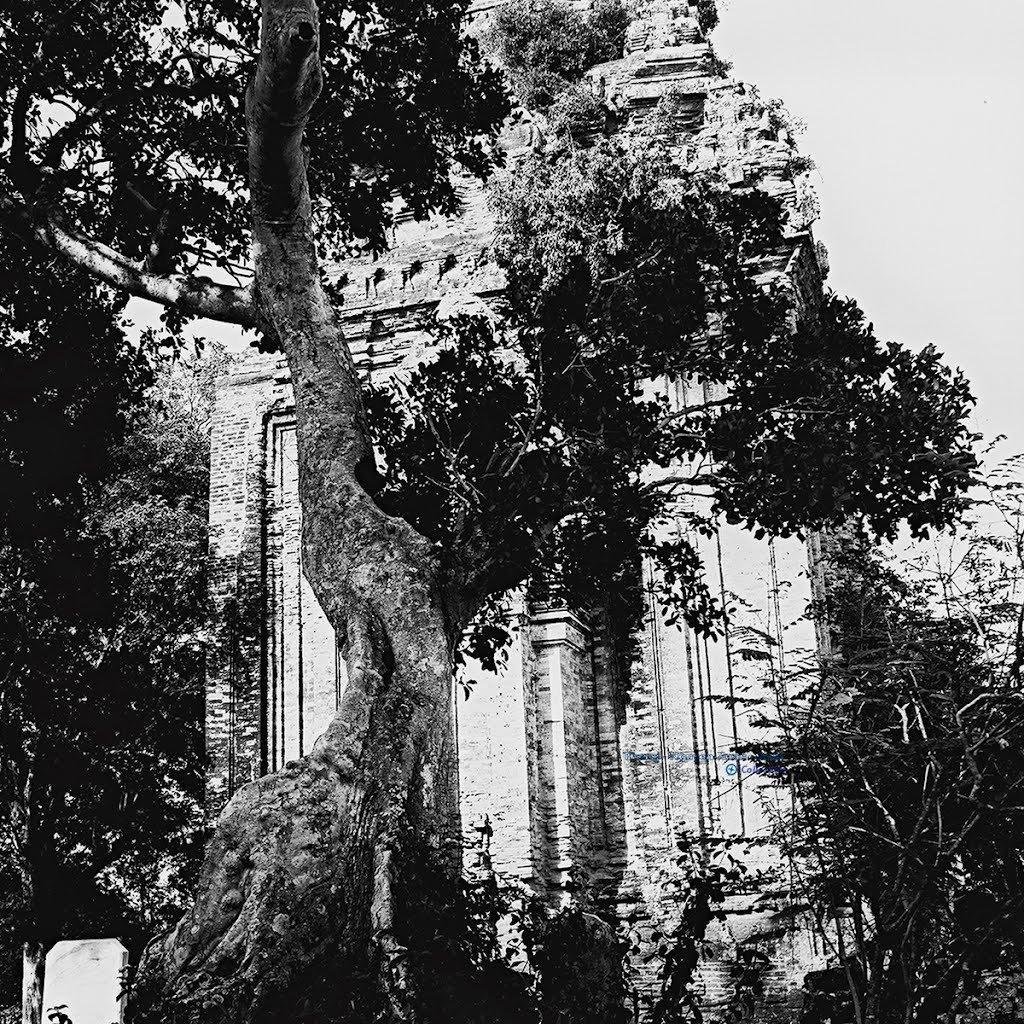Can you describe this image briefly? This is a black and white picture and in this picture we can see a building, stone, trees and in the background we can see the sky. 